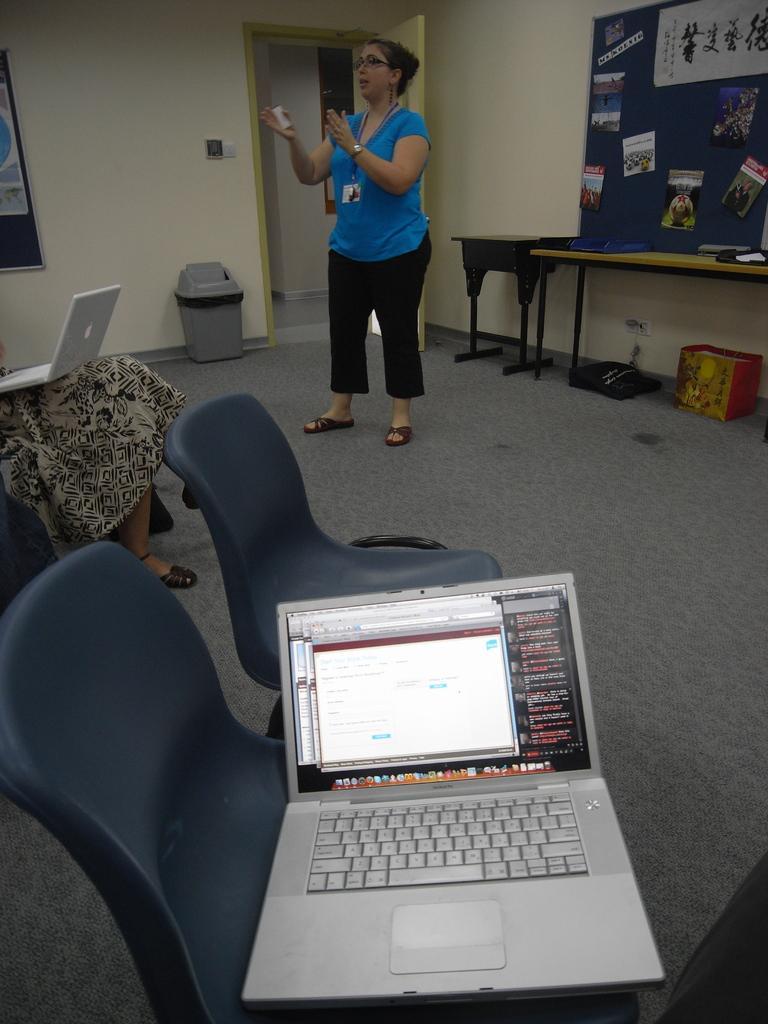Can you describe this image briefly? in this picture we see a room and a notice board and a person standing and two chairs on the chair we can see a laptop and on the other chair we can see a woman seated and a laptop on her lap. 